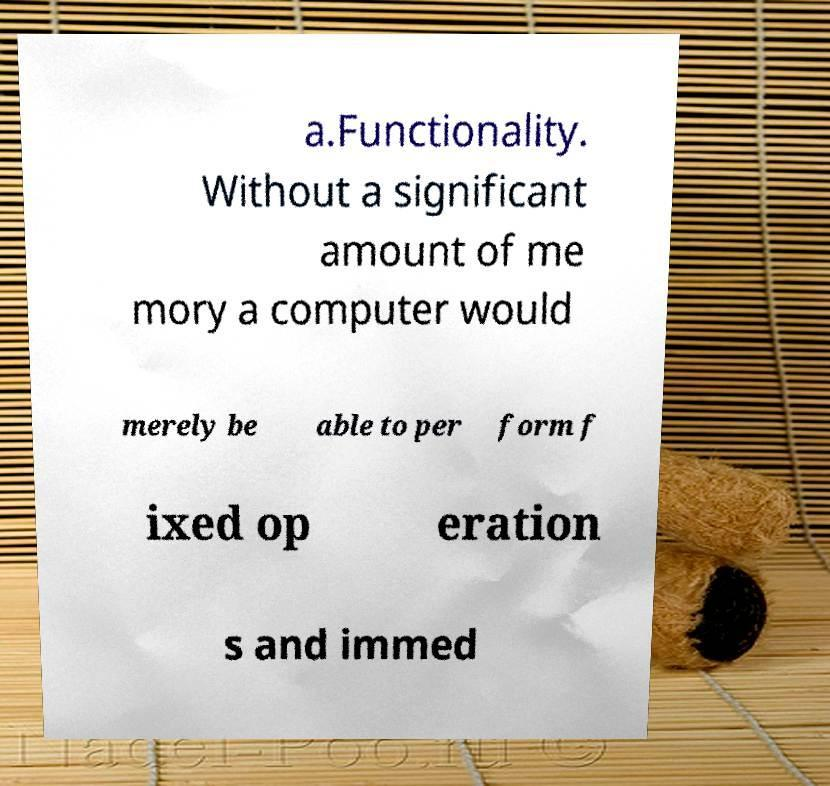What messages or text are displayed in this image? I need them in a readable, typed format. a.Functionality. Without a significant amount of me mory a computer would merely be able to per form f ixed op eration s and immed 